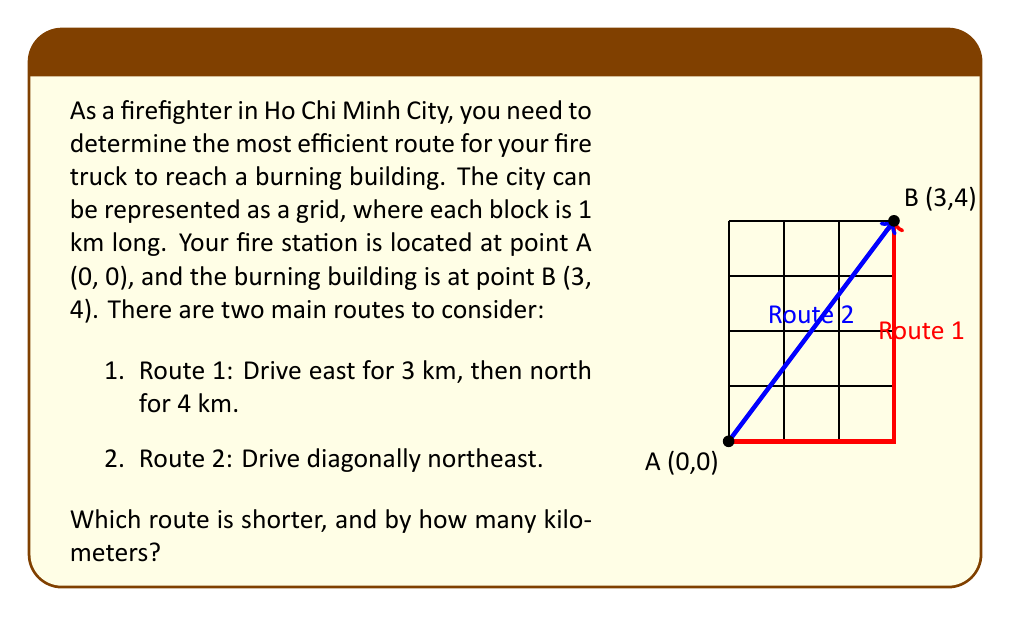Help me with this question. To solve this problem, we need to calculate the length of each route and compare them:

1. Route 1:
   This route follows the grid, so we can simply add the horizontal and vertical distances.
   Length of Route 1 = 3 km + 4 km = 7 km

2. Route 2:
   This route forms the hypotenuse of a right triangle. We can use the Pythagorean theorem to calculate its length.
   
   Let the length of Route 2 be $x$.
   
   $$x^2 = 3^2 + 4^2$$
   $$x^2 = 9 + 16 = 25$$
   $$x = \sqrt{25} = 5$$

   So, the length of Route 2 is 5 km.

Comparing the two routes:
Route 1 is 7 km long
Route 2 is 5 km long

The difference is:
7 km - 5 km = 2 km

Therefore, Route 2 (the diagonal route) is shorter by 2 km.
Answer: Route 2; 2 km 